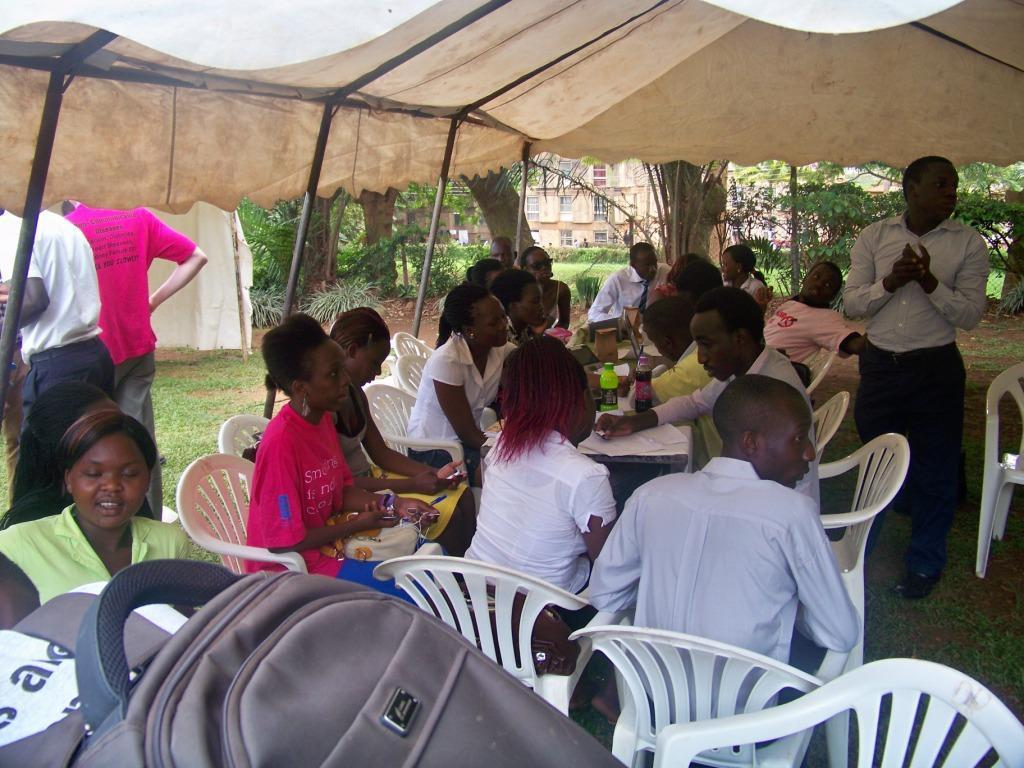What structure is present in the image? There is a tent in the image. What are the people in the image doing? The people in the image are sitting on chairs. Where are the chairs located in relation to the tables? The chairs are in front of the tables. What can be seen on the tables in the image? There are bottles visible on the tables. What type of bags can be seen in the image? There are backpacks in the image. What color is the blood on the truck in the image? There is no truck or blood present in the image. How does the disgust in the image make you feel? There is no indication of disgust in the image, as it features a tent, chairs, tables, bottles, and backpacks. 